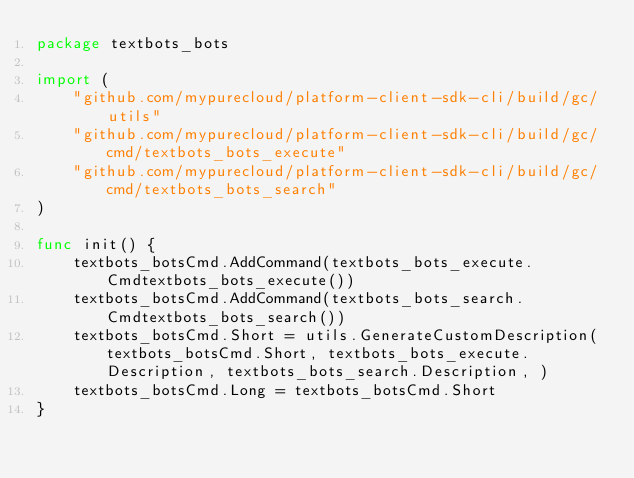<code> <loc_0><loc_0><loc_500><loc_500><_Go_>package textbots_bots

import (
	"github.com/mypurecloud/platform-client-sdk-cli/build/gc/utils"
	"github.com/mypurecloud/platform-client-sdk-cli/build/gc/cmd/textbots_bots_execute"
	"github.com/mypurecloud/platform-client-sdk-cli/build/gc/cmd/textbots_bots_search"
)

func init() {
	textbots_botsCmd.AddCommand(textbots_bots_execute.Cmdtextbots_bots_execute())
	textbots_botsCmd.AddCommand(textbots_bots_search.Cmdtextbots_bots_search())
	textbots_botsCmd.Short = utils.GenerateCustomDescription(textbots_botsCmd.Short, textbots_bots_execute.Description, textbots_bots_search.Description, )
	textbots_botsCmd.Long = textbots_botsCmd.Short
}
</code> 